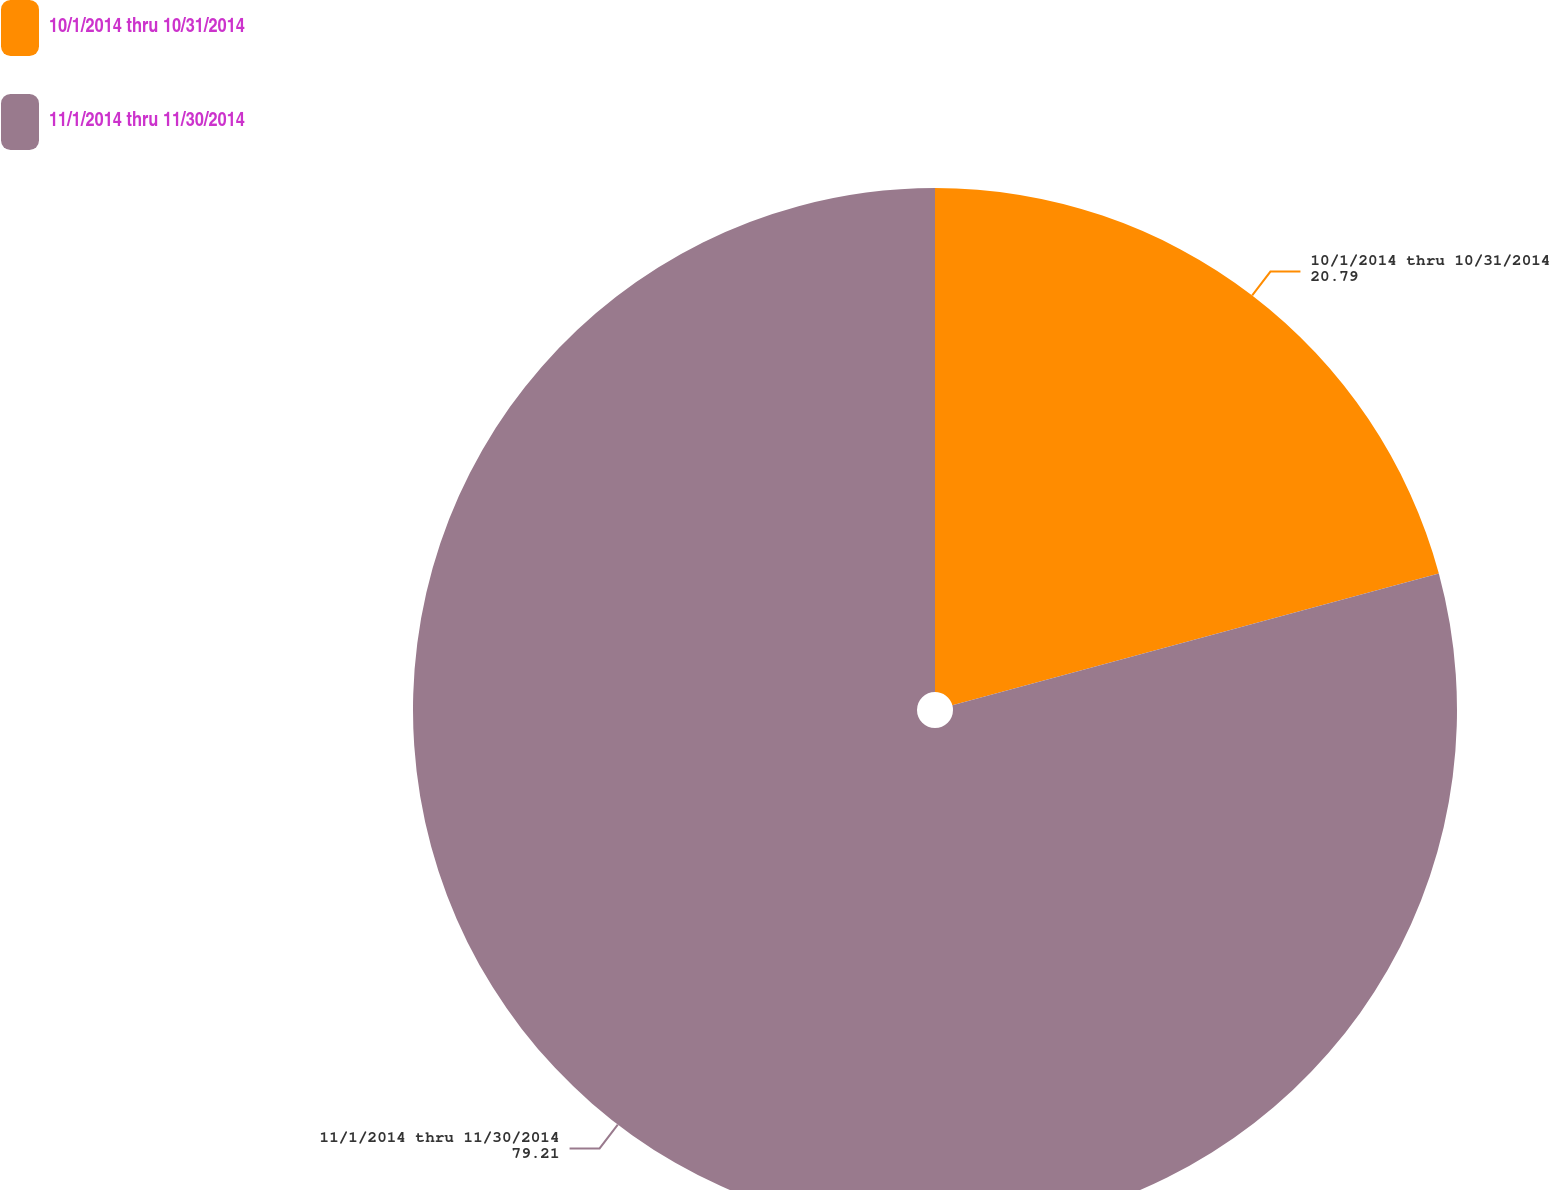Convert chart. <chart><loc_0><loc_0><loc_500><loc_500><pie_chart><fcel>10/1/2014 thru 10/31/2014<fcel>11/1/2014 thru 11/30/2014<nl><fcel>20.79%<fcel>79.21%<nl></chart> 